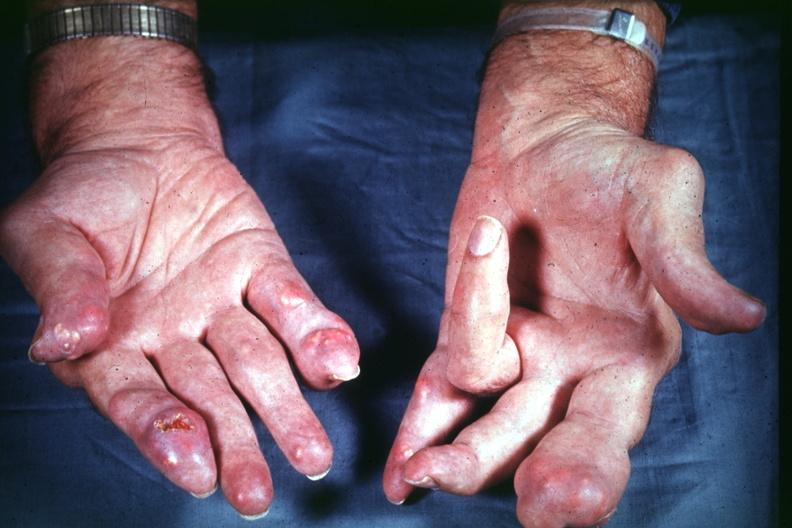does feet show good example source of gout?
Answer the question using a single word or phrase. No 